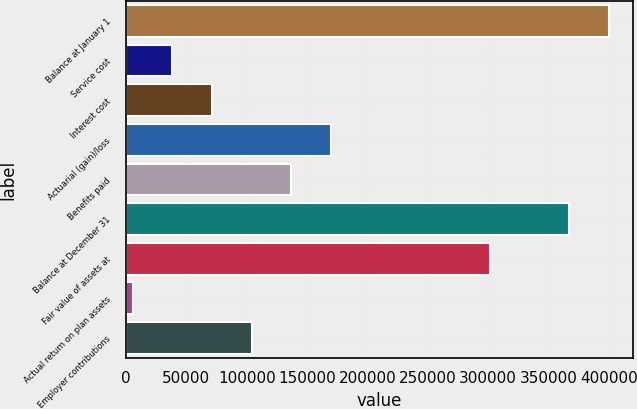<chart> <loc_0><loc_0><loc_500><loc_500><bar_chart><fcel>Balance at January 1<fcel>Service cost<fcel>Interest cost<fcel>Actuarial (gain)/loss<fcel>Benefits paid<fcel>Balance at December 31<fcel>Fair value of assets at<fcel>Actual return on plan assets<fcel>Employer contributions<nl><fcel>400064<fcel>38426.2<fcel>71302.4<fcel>169931<fcel>137055<fcel>367188<fcel>301436<fcel>5550<fcel>104179<nl></chart> 